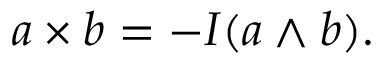Convert formula to latex. <formula><loc_0><loc_0><loc_500><loc_500>a \times b = - I ( a \wedge b ) .</formula> 